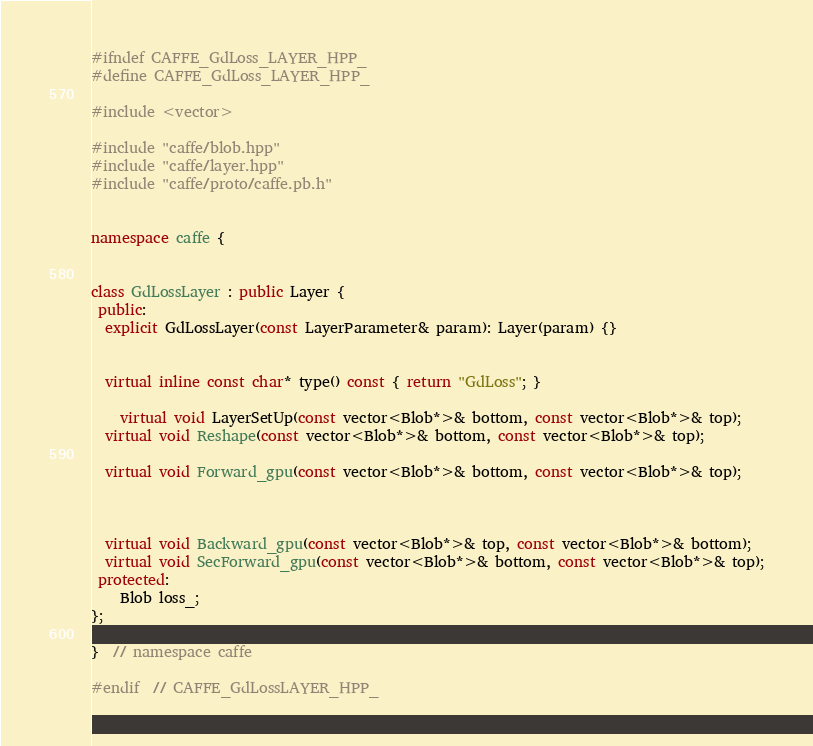Convert code to text. <code><loc_0><loc_0><loc_500><loc_500><_C++_>
#ifndef CAFFE_GdLoss_LAYER_HPP_
#define CAFFE_GdLoss_LAYER_HPP_

#include <vector>

#include "caffe/blob.hpp"
#include "caffe/layer.hpp"
#include "caffe/proto/caffe.pb.h"


namespace caffe {


class GdLossLayer : public Layer {
 public:
  explicit GdLossLayer(const LayerParameter& param): Layer(param) {}
  

  virtual inline const char* type() const { return "GdLoss"; }
	
	virtual void LayerSetUp(const vector<Blob*>& bottom, const vector<Blob*>& top);
  virtual void Reshape(const vector<Blob*>& bottom, const vector<Blob*>& top);

  virtual void Forward_gpu(const vector<Blob*>& bottom, const vector<Blob*>& top);



  virtual void Backward_gpu(const vector<Blob*>& top, const vector<Blob*>& bottom);
  virtual void SecForward_gpu(const vector<Blob*>& bottom, const vector<Blob*>& top);
 protected:
 	Blob loss_;
};

}  // namespace caffe

#endif  // CAFFE_GdLossLAYER_HPP_
</code> 